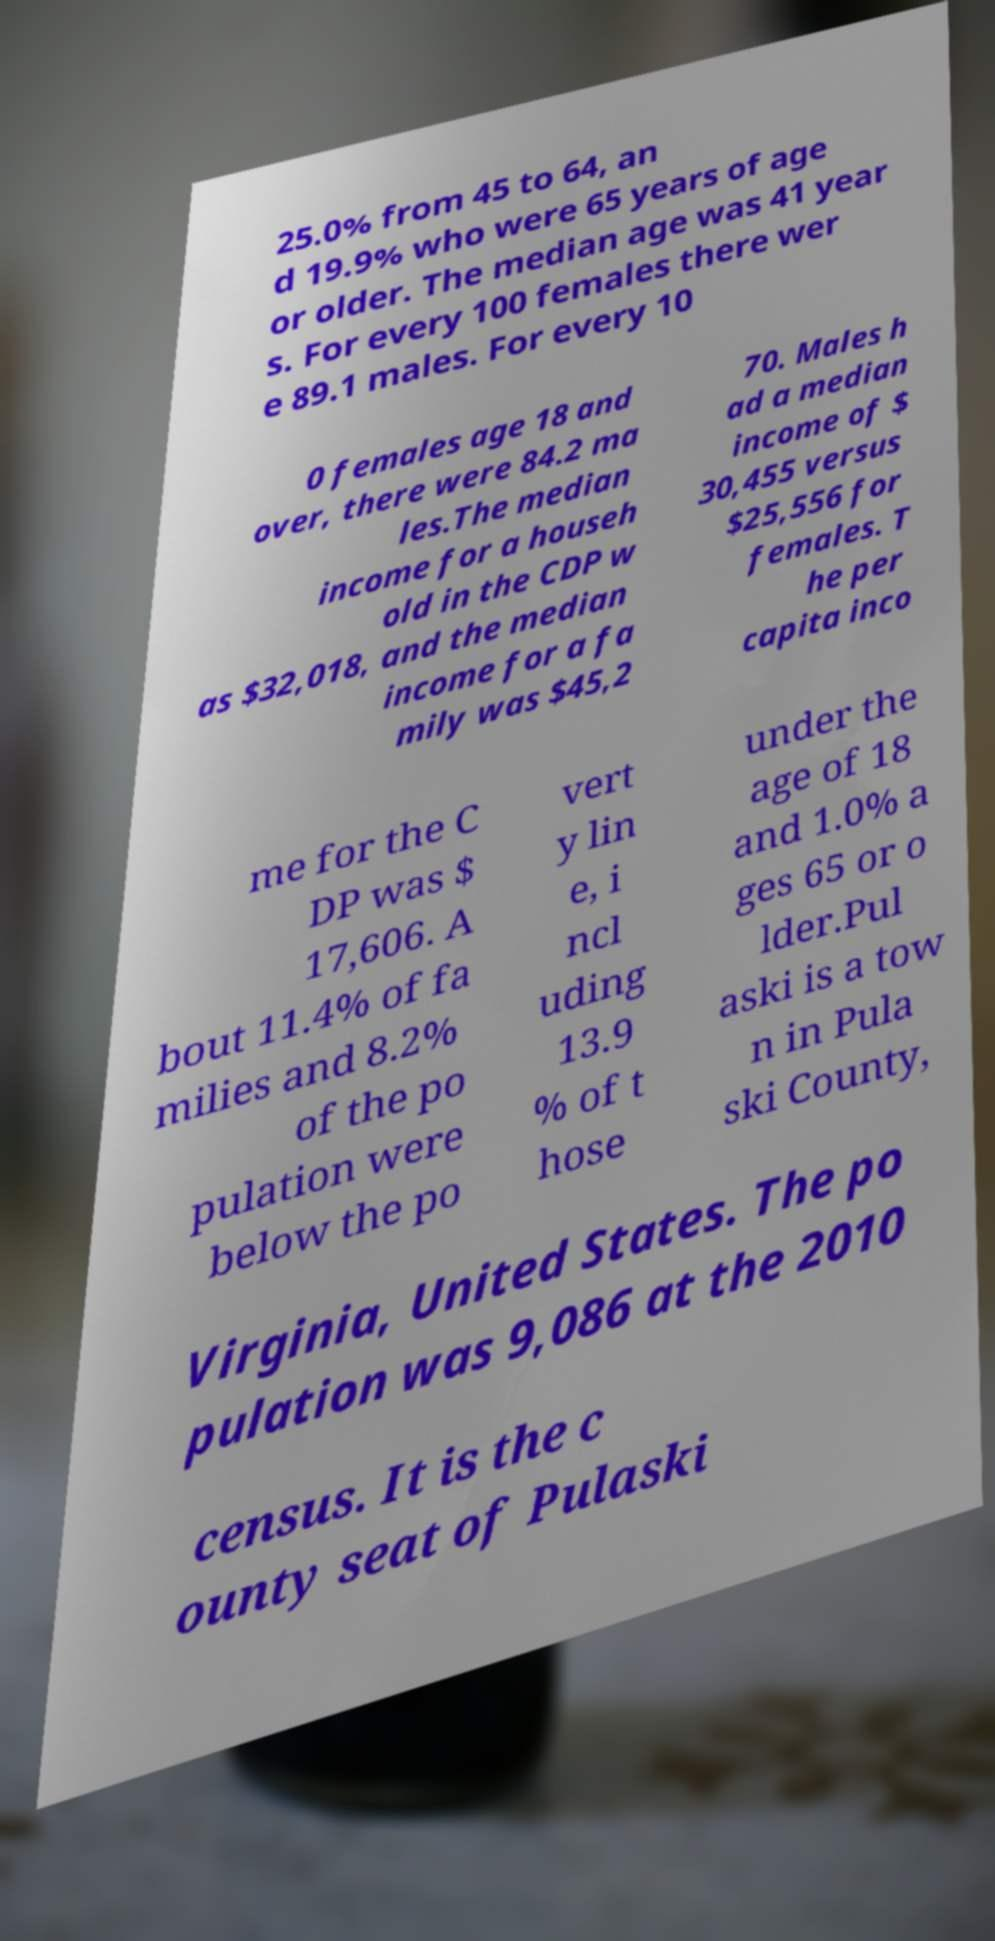Please read and relay the text visible in this image. What does it say? 25.0% from 45 to 64, an d 19.9% who were 65 years of age or older. The median age was 41 year s. For every 100 females there wer e 89.1 males. For every 10 0 females age 18 and over, there were 84.2 ma les.The median income for a househ old in the CDP w as $32,018, and the median income for a fa mily was $45,2 70. Males h ad a median income of $ 30,455 versus $25,556 for females. T he per capita inco me for the C DP was $ 17,606. A bout 11.4% of fa milies and 8.2% of the po pulation were below the po vert y lin e, i ncl uding 13.9 % of t hose under the age of 18 and 1.0% a ges 65 or o lder.Pul aski is a tow n in Pula ski County, Virginia, United States. The po pulation was 9,086 at the 2010 census. It is the c ounty seat of Pulaski 